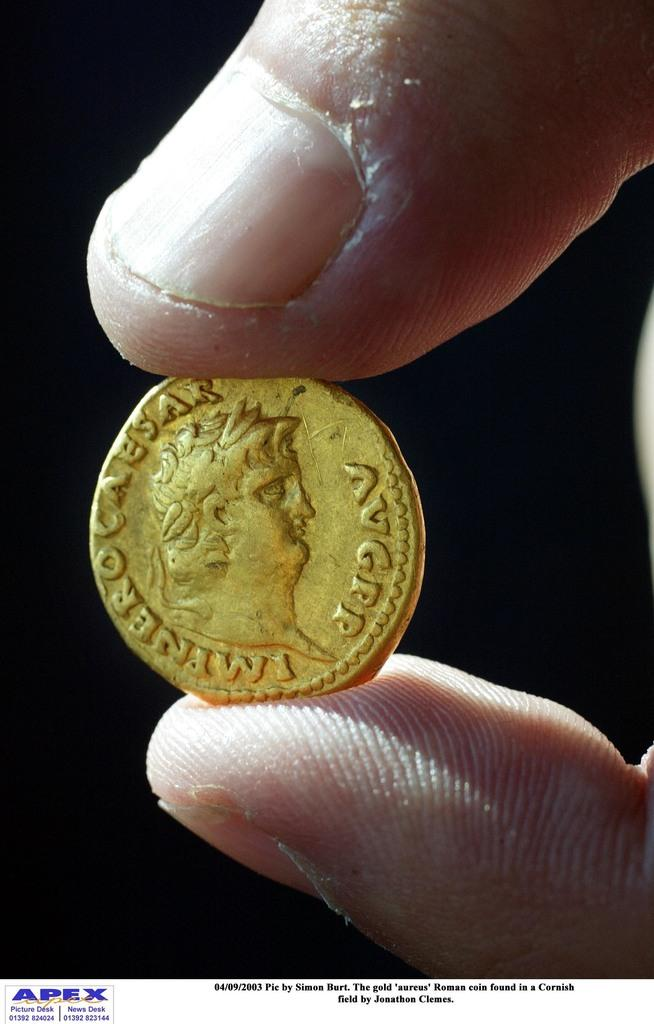<image>
Write a terse but informative summary of the picture. An old looking gold coin which has the name Caesar on it 